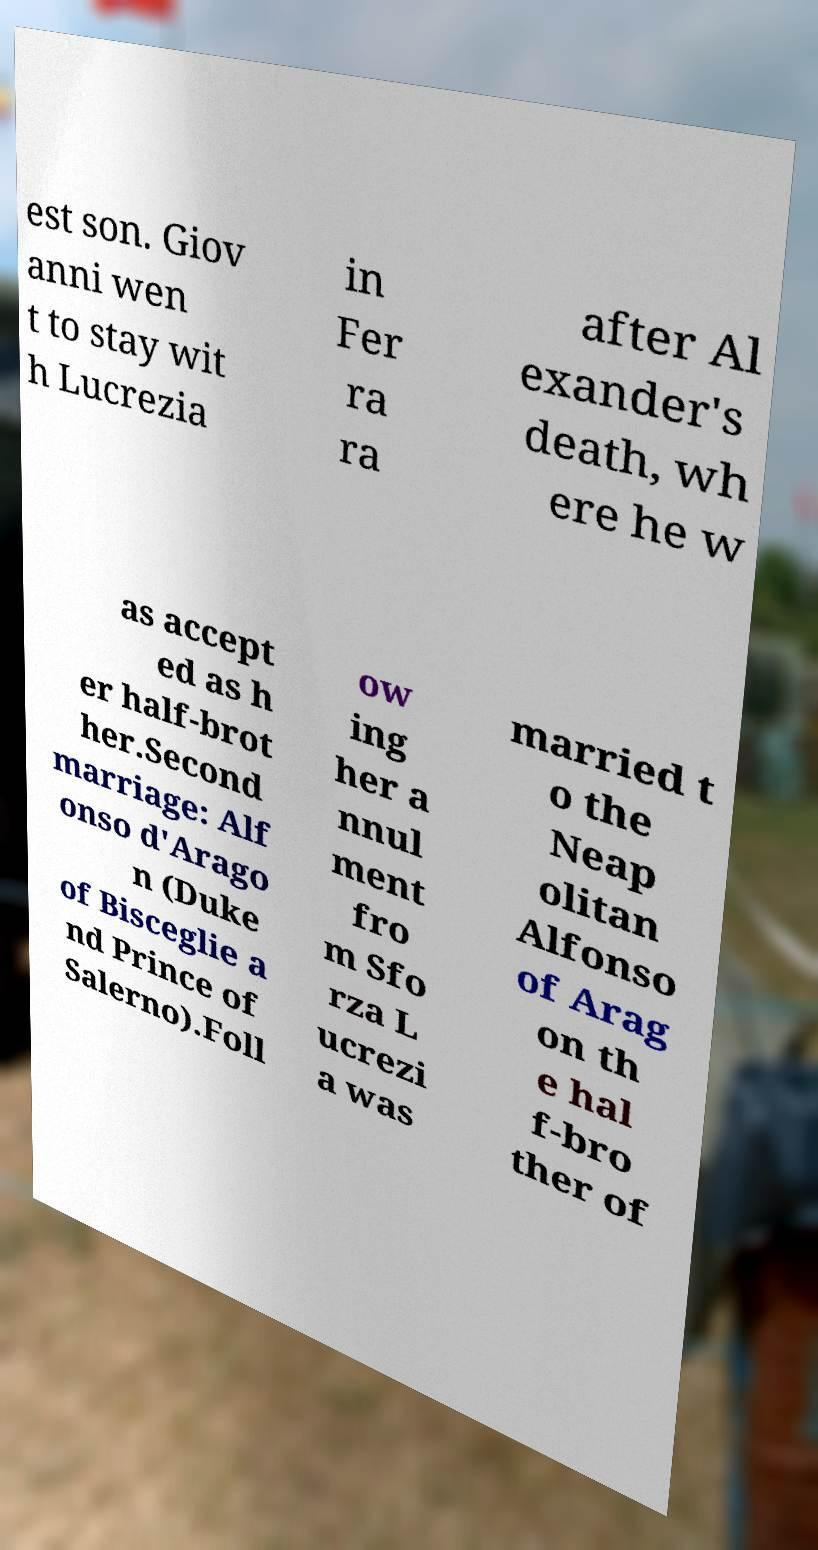Could you assist in decoding the text presented in this image and type it out clearly? est son. Giov anni wen t to stay wit h Lucrezia in Fer ra ra after Al exander's death, wh ere he w as accept ed as h er half-brot her.Second marriage: Alf onso d'Arago n (Duke of Bisceglie a nd Prince of Salerno).Foll ow ing her a nnul ment fro m Sfo rza L ucrezi a was married t o the Neap olitan Alfonso of Arag on th e hal f-bro ther of 